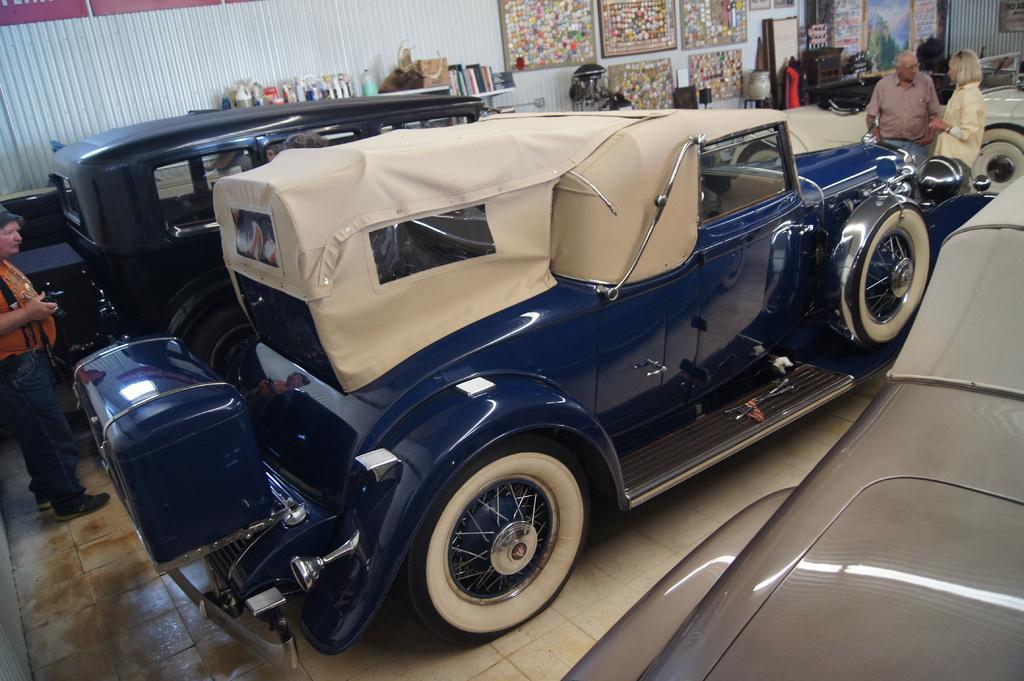How would you summarize this image in a sentence or two? in this picture we can see the different types of cars in the shed in which we can see the frames ,in which we can also see the persons standing near the car 